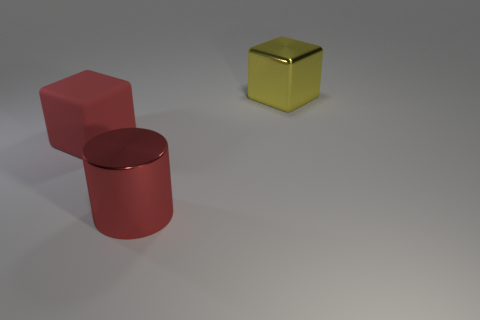Add 2 green metal things. How many objects exist? 5 Subtract all blocks. How many objects are left? 1 Subtract 0 green cylinders. How many objects are left? 3 Subtract all big yellow blocks. Subtract all blocks. How many objects are left? 0 Add 1 big matte objects. How many big matte objects are left? 2 Add 3 large matte objects. How many large matte objects exist? 4 